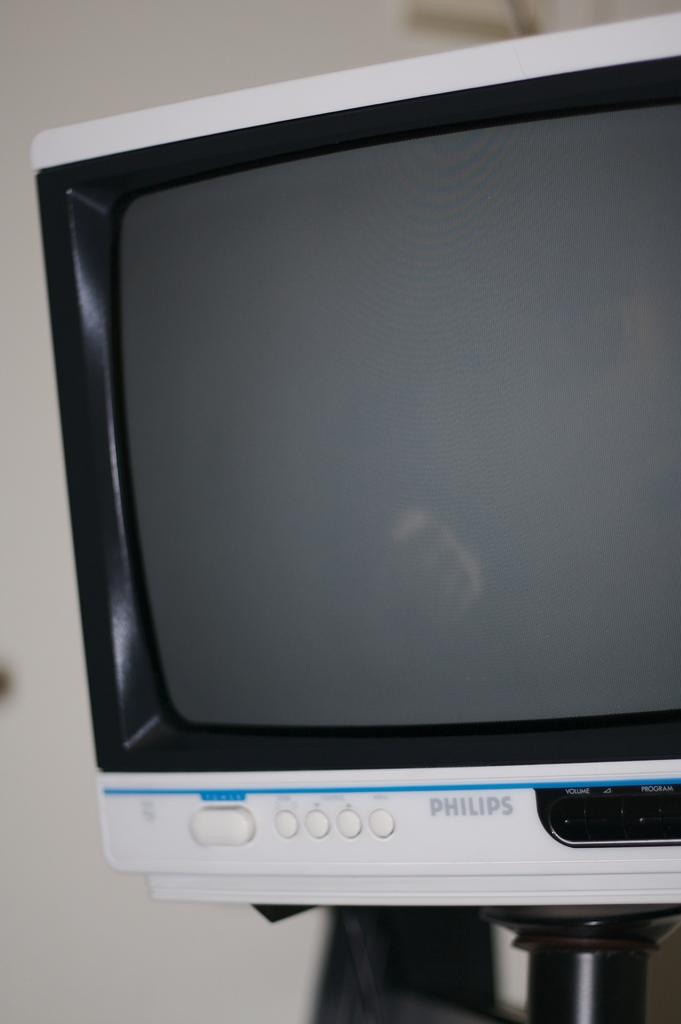<image>
Give a short and clear explanation of the subsequent image. Older version of a TV Screen from Phillips. 